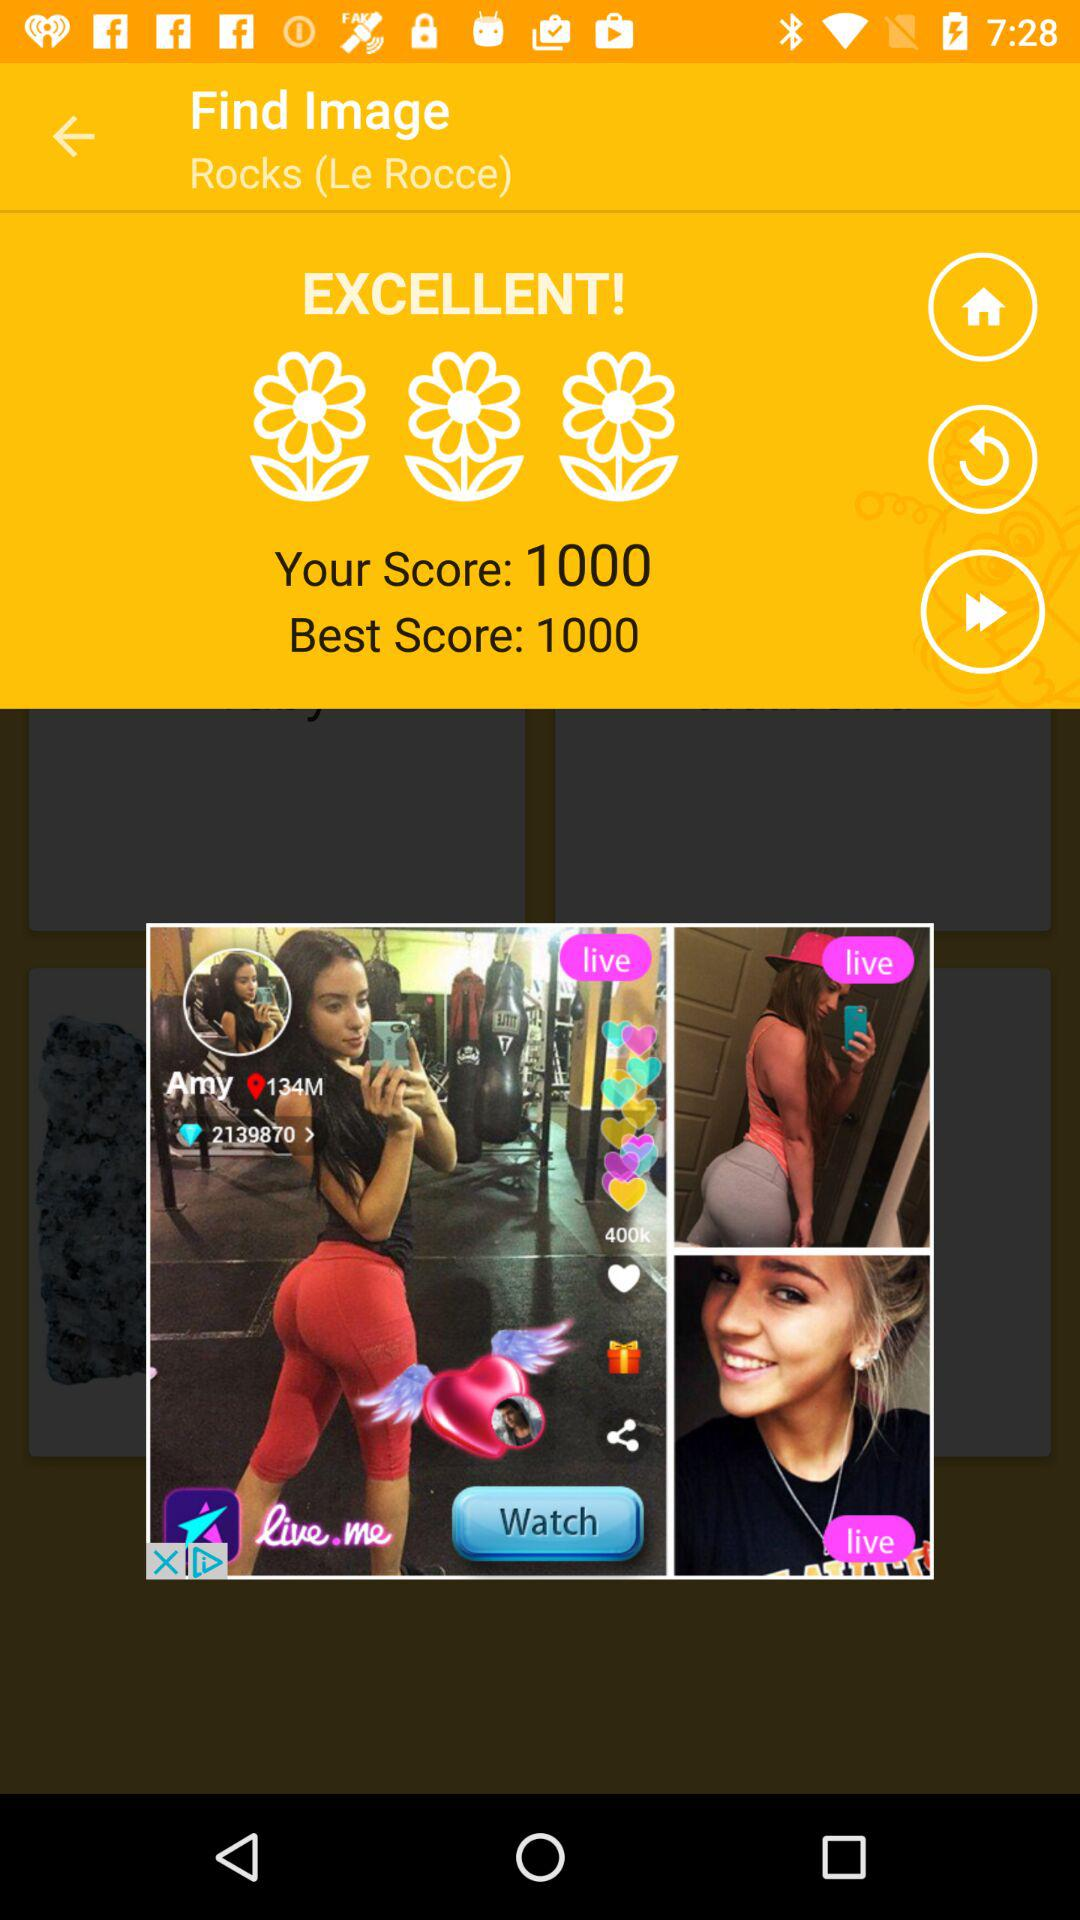What is the best score? The best score is 1000. 